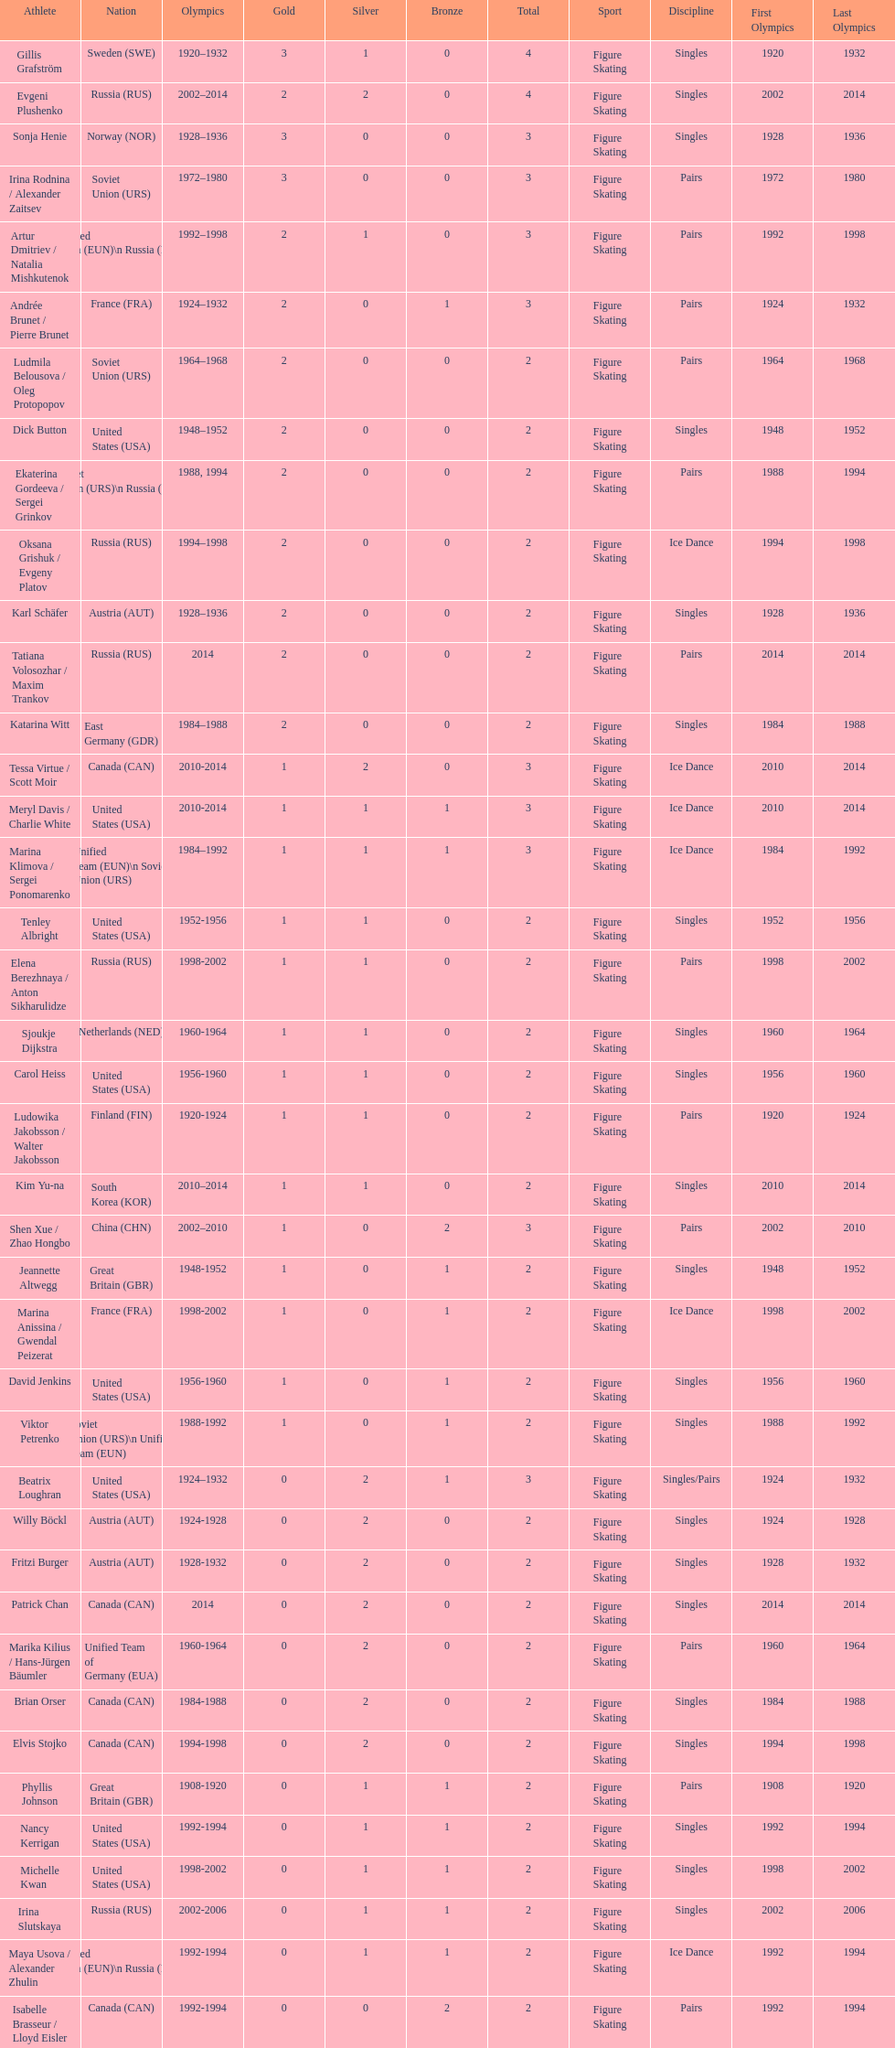What was the greatest number of gold medals won by a single athlete? 3. 